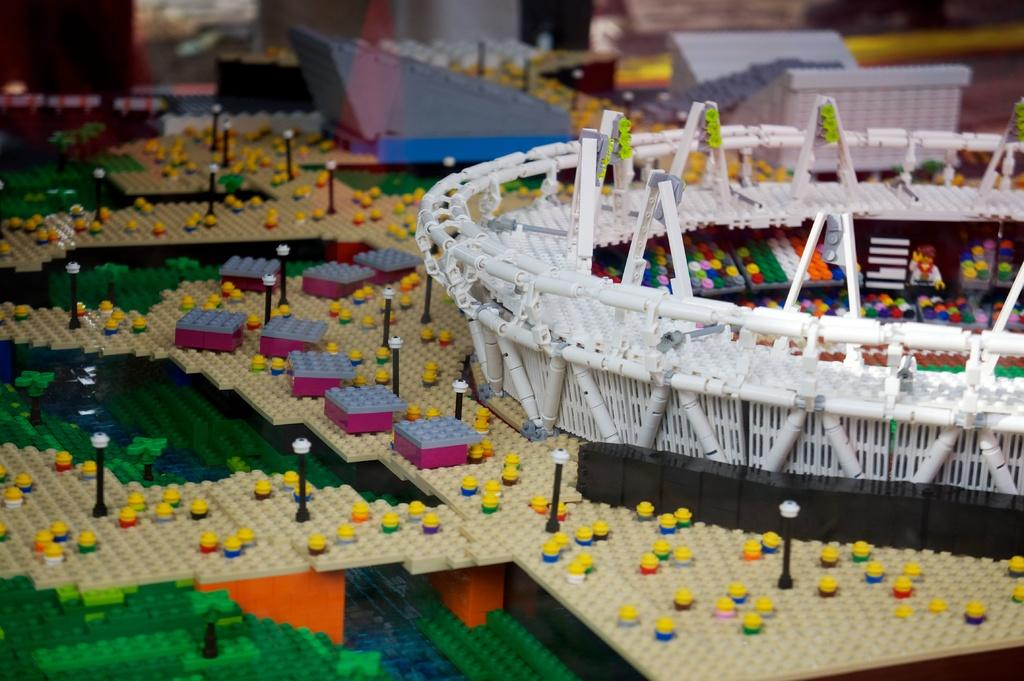What type of objects can be seen in the image? There are toys, poles, boxes, and objects made of Lego in the image. Can you describe the toys in the image? The toys in the image are not specified, but they are present. What are the poles used for in the image? The purpose of the poles in the image is not mentioned, but they are present. What type of objects are the boxes in the image? The boxes in the image are not specified, but they are present. Where is the mom in the image? There is no mom present in the image. What type of vacation is depicted in the image? There is no vacation depicted in the image. Can you see any steam coming from the objects in the image? There is no steam present in the image. 